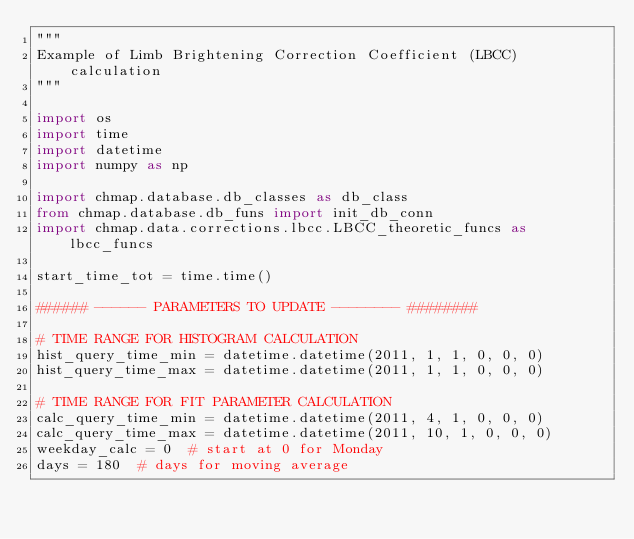Convert code to text. <code><loc_0><loc_0><loc_500><loc_500><_Python_>"""
Example of Limb Brightening Correction Coefficient (LBCC) calculation
"""

import os
import time
import datetime
import numpy as np

import chmap.database.db_classes as db_class
from chmap.database.db_funs import init_db_conn
import chmap.data.corrections.lbcc.LBCC_theoretic_funcs as lbcc_funcs

start_time_tot = time.time()

###### ------ PARAMETERS TO UPDATE -------- ########

# TIME RANGE FOR HISTOGRAM CALCULATION
hist_query_time_min = datetime.datetime(2011, 1, 1, 0, 0, 0)
hist_query_time_max = datetime.datetime(2011, 1, 1, 0, 0, 0)

# TIME RANGE FOR FIT PARAMETER CALCULATION
calc_query_time_min = datetime.datetime(2011, 4, 1, 0, 0, 0)
calc_query_time_max = datetime.datetime(2011, 10, 1, 0, 0, 0)
weekday_calc = 0  # start at 0 for Monday
days = 180  # days for moving average</code> 